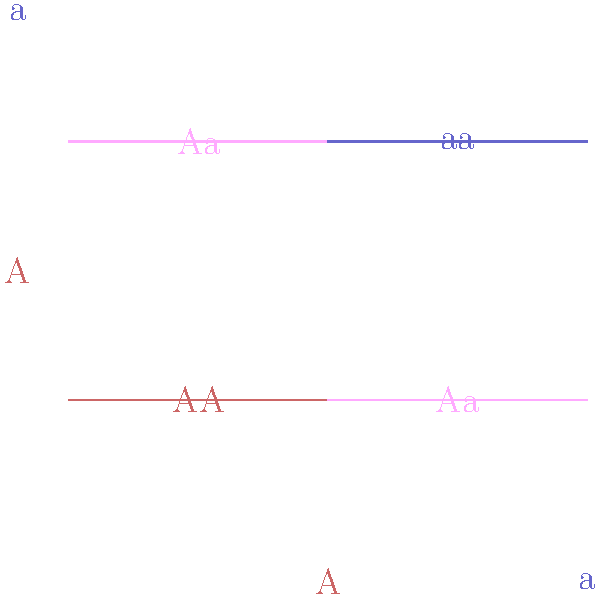A mother carries one dominant allele (A) and one recessive allele (a) for a certain genetic condition. The father has the same genetic makeup (Aa). Using the Punnett square diagram provided, what is the probability that their child will have the dominant phenotype (express the trait)? To solve this problem, we need to follow these steps:

1. Identify the genotypes of the parents:
   Mother: Aa
   Father: Aa

2. Set up the Punnett square (as shown in the diagram):
   - The mother's alleles (A and a) are on the left side
   - The father's alleles (A and a) are on the top

3. Fill in the Punnett square by combining the alleles:
   AA, Aa, Aa, aa

4. Count the number of outcomes with the dominant phenotype:
   - AA (dominant)
   - Aa (dominant)
   - Aa (dominant)
   - aa (recessive)

5. Calculate the probability:
   - Total outcomes: 4
   - Outcomes with dominant phenotype: 3
   - Probability = $\frac{\text{Favorable outcomes}}{\text{Total outcomes}} = \frac{3}{4} = 0.75$ or $75\%$

The dominant phenotype will be expressed when at least one dominant allele (A) is present. This occurs in 3 out of 4 possible outcomes (AA and Aa).
Answer: $\frac{3}{4}$ or $75\%$ 